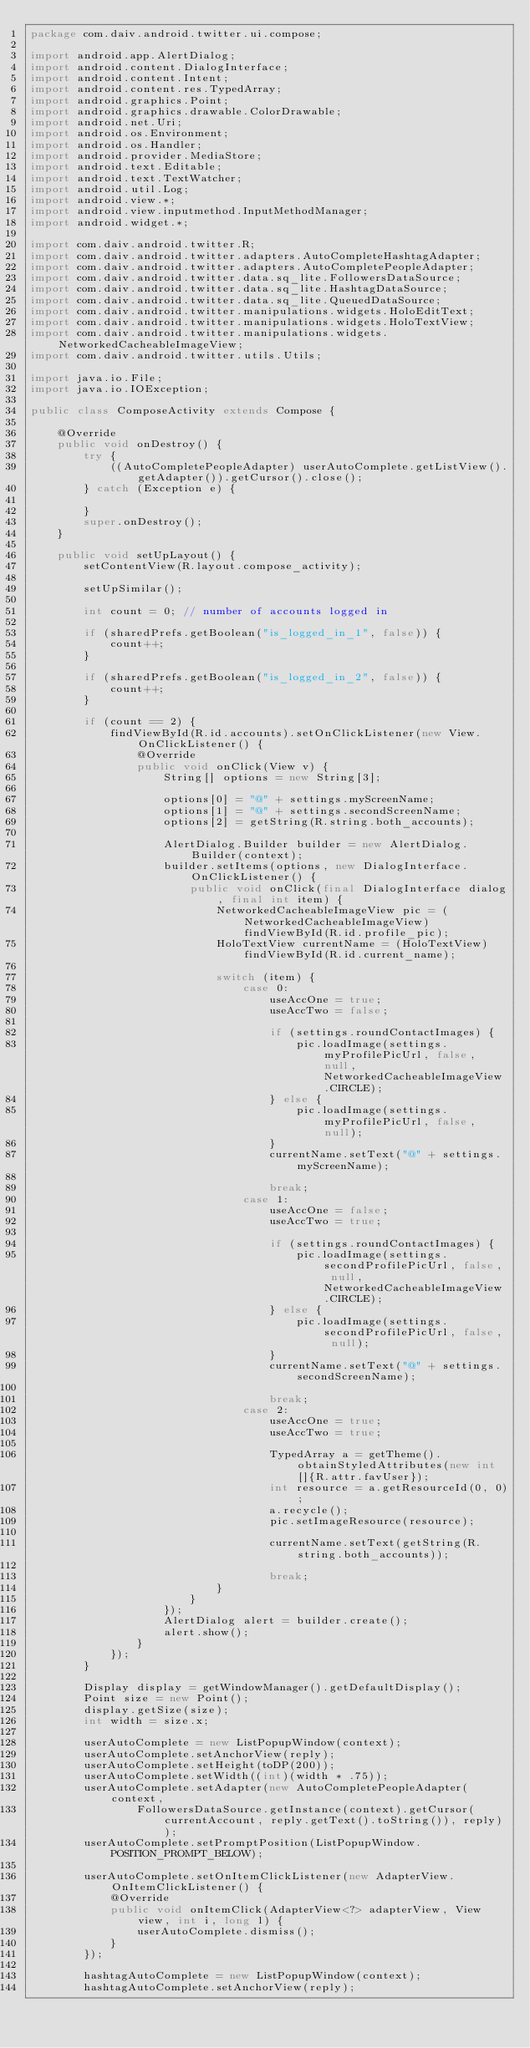<code> <loc_0><loc_0><loc_500><loc_500><_Java_>package com.daiv.android.twitter.ui.compose;

import android.app.AlertDialog;
import android.content.DialogInterface;
import android.content.Intent;
import android.content.res.TypedArray;
import android.graphics.Point;
import android.graphics.drawable.ColorDrawable;
import android.net.Uri;
import android.os.Environment;
import android.os.Handler;
import android.provider.MediaStore;
import android.text.Editable;
import android.text.TextWatcher;
import android.util.Log;
import android.view.*;
import android.view.inputmethod.InputMethodManager;
import android.widget.*;

import com.daiv.android.twitter.R;
import com.daiv.android.twitter.adapters.AutoCompleteHashtagAdapter;
import com.daiv.android.twitter.adapters.AutoCompletePeopleAdapter;
import com.daiv.android.twitter.data.sq_lite.FollowersDataSource;
import com.daiv.android.twitter.data.sq_lite.HashtagDataSource;
import com.daiv.android.twitter.data.sq_lite.QueuedDataSource;
import com.daiv.android.twitter.manipulations.widgets.HoloEditText;
import com.daiv.android.twitter.manipulations.widgets.HoloTextView;
import com.daiv.android.twitter.manipulations.widgets.NetworkedCacheableImageView;
import com.daiv.android.twitter.utils.Utils;

import java.io.File;
import java.io.IOException;

public class ComposeActivity extends Compose {

    @Override
    public void onDestroy() {
        try {
            ((AutoCompletePeopleAdapter) userAutoComplete.getListView().getAdapter()).getCursor().close();
        } catch (Exception e) {

        }
        super.onDestroy();
    }

    public void setUpLayout() {
        setContentView(R.layout.compose_activity);

        setUpSimilar();

        int count = 0; // number of accounts logged in

        if (sharedPrefs.getBoolean("is_logged_in_1", false)) {
            count++;
        }

        if (sharedPrefs.getBoolean("is_logged_in_2", false)) {
            count++;
        }

        if (count == 2) {
            findViewById(R.id.accounts).setOnClickListener(new View.OnClickListener() {
                @Override
                public void onClick(View v) {
                    String[] options = new String[3];

                    options[0] = "@" + settings.myScreenName;
                    options[1] = "@" + settings.secondScreenName;
                    options[2] = getString(R.string.both_accounts);

                    AlertDialog.Builder builder = new AlertDialog.Builder(context);
                    builder.setItems(options, new DialogInterface.OnClickListener() {
                        public void onClick(final DialogInterface dialog, final int item) {
                            NetworkedCacheableImageView pic = (NetworkedCacheableImageView) findViewById(R.id.profile_pic);
                            HoloTextView currentName = (HoloTextView) findViewById(R.id.current_name);

                            switch (item) {
                                case 0:
                                    useAccOne = true;
                                    useAccTwo = false;

                                    if (settings.roundContactImages) {
                                        pic.loadImage(settings.myProfilePicUrl, false, null, NetworkedCacheableImageView.CIRCLE);
                                    } else {
                                        pic.loadImage(settings.myProfilePicUrl, false, null);
                                    }
                                    currentName.setText("@" + settings.myScreenName);

                                    break;
                                case 1:
                                    useAccOne = false;
                                    useAccTwo = true;

                                    if (settings.roundContactImages) {
                                        pic.loadImage(settings.secondProfilePicUrl, false, null, NetworkedCacheableImageView.CIRCLE);
                                    } else {
                                        pic.loadImage(settings.secondProfilePicUrl, false, null);
                                    }
                                    currentName.setText("@" + settings.secondScreenName);

                                    break;
                                case 2:
                                    useAccOne = true;
                                    useAccTwo = true;

                                    TypedArray a = getTheme().obtainStyledAttributes(new int[]{R.attr.favUser});
                                    int resource = a.getResourceId(0, 0);
                                    a.recycle();
                                    pic.setImageResource(resource);

                                    currentName.setText(getString(R.string.both_accounts));

                                    break;
                            }
                        }
                    });
                    AlertDialog alert = builder.create();
                    alert.show();
                }
            });
        }

        Display display = getWindowManager().getDefaultDisplay();
        Point size = new Point();
        display.getSize(size);
        int width = size.x;

        userAutoComplete = new ListPopupWindow(context);
        userAutoComplete.setAnchorView(reply);
        userAutoComplete.setHeight(toDP(200));
        userAutoComplete.setWidth((int)(width * .75));
        userAutoComplete.setAdapter(new AutoCompletePeopleAdapter(context,
                FollowersDataSource.getInstance(context).getCursor(currentAccount, reply.getText().toString()), reply));
        userAutoComplete.setPromptPosition(ListPopupWindow.POSITION_PROMPT_BELOW);

        userAutoComplete.setOnItemClickListener(new AdapterView.OnItemClickListener() {
            @Override
            public void onItemClick(AdapterView<?> adapterView, View view, int i, long l) {
                userAutoComplete.dismiss();
            }
        });

        hashtagAutoComplete = new ListPopupWindow(context);
        hashtagAutoComplete.setAnchorView(reply);</code> 